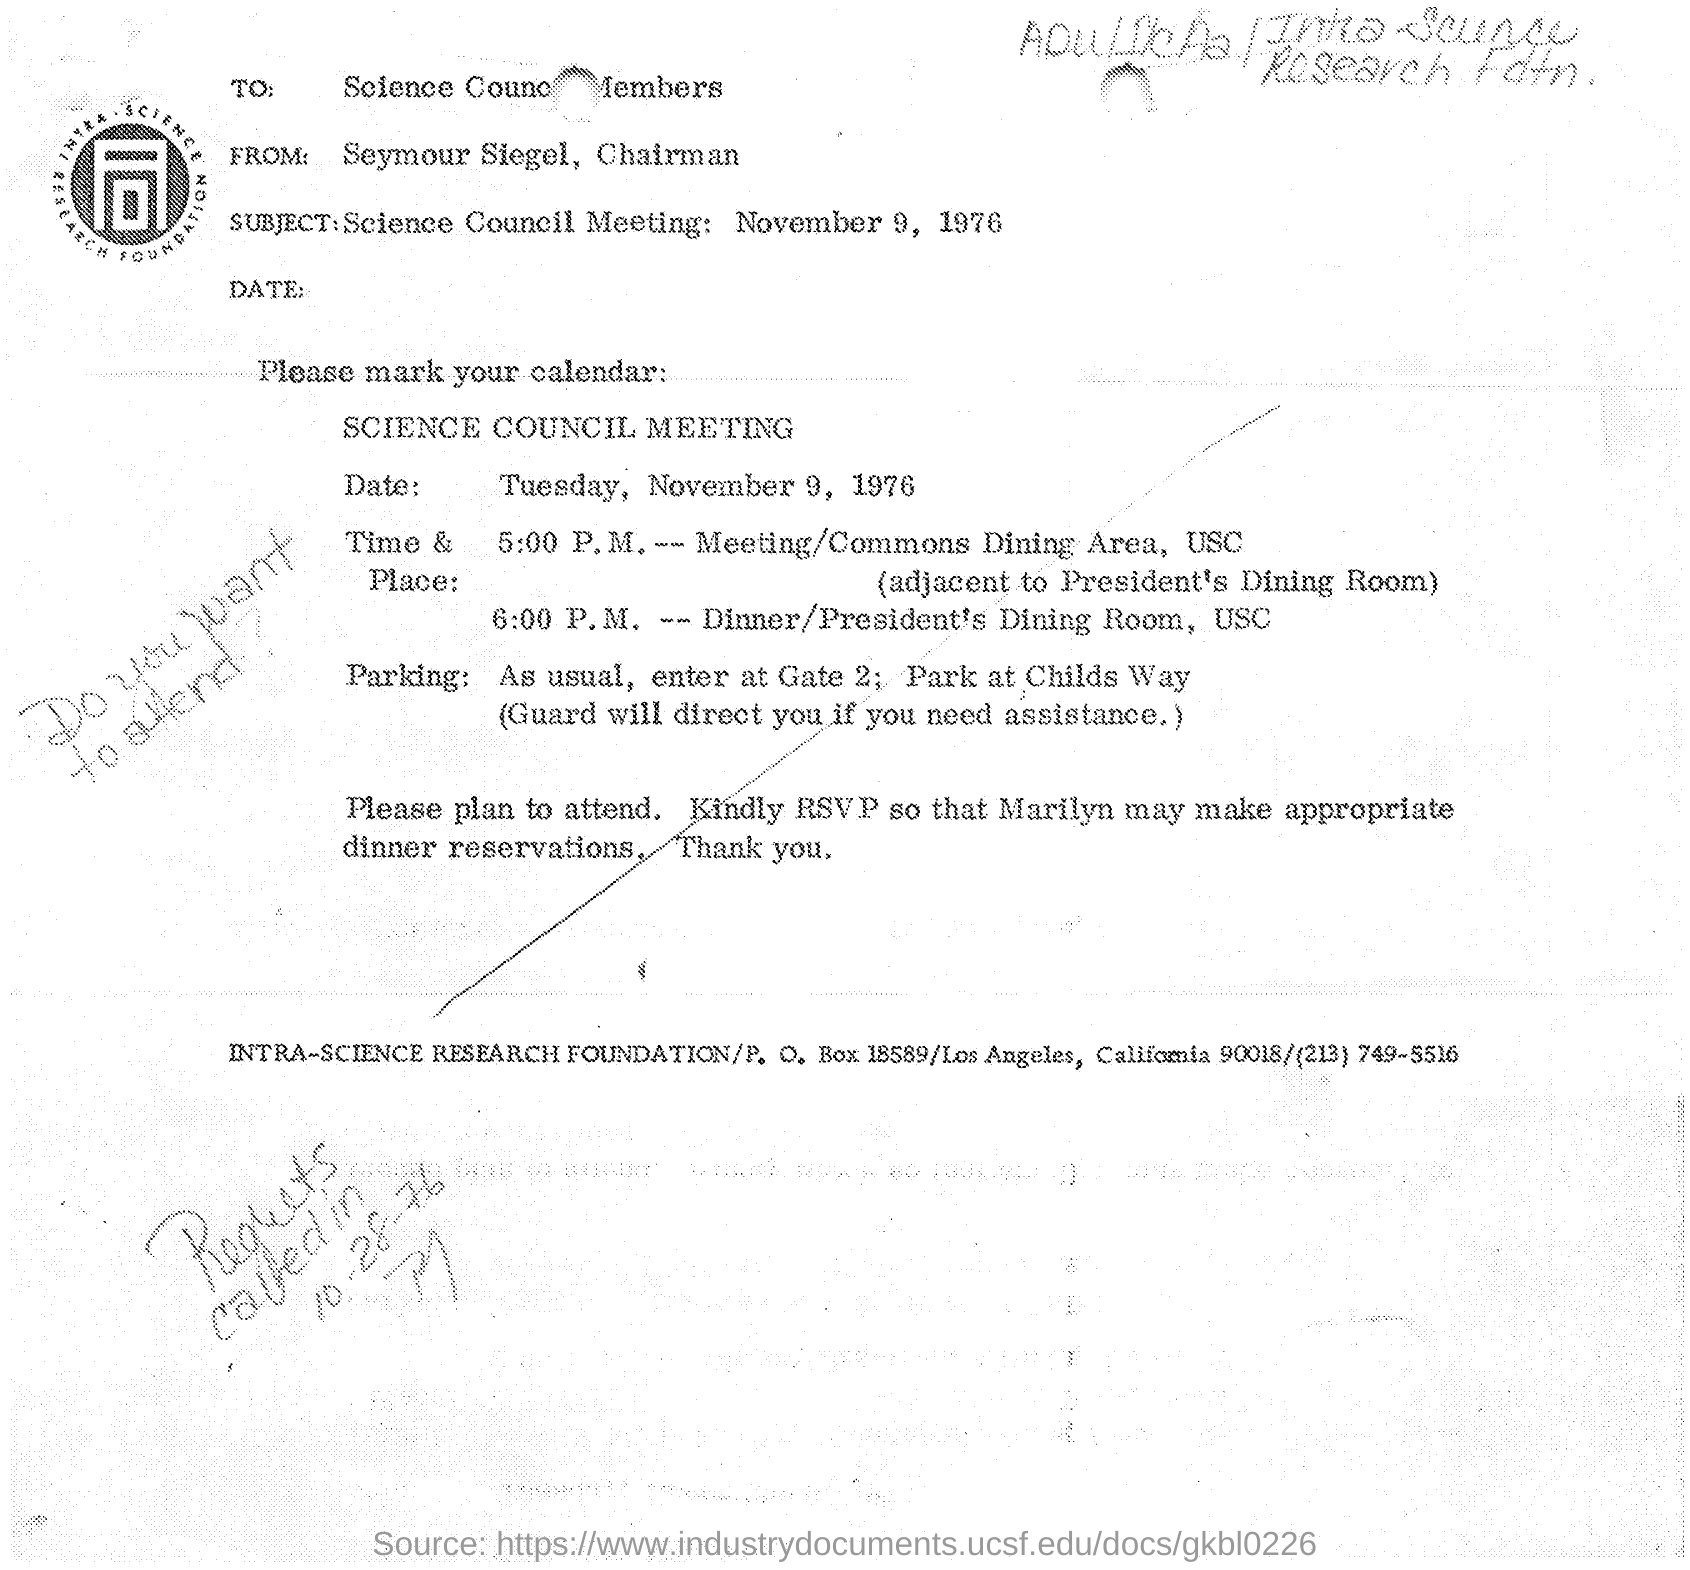Mention a couple of crucial points in this snapshot. The sender of this document is Seymour Siegel, its Chairman. This is the schedule of the meeting of INTRA-SCIENCE RESEARCH FOUNDATION. The Science Council Meeting will be held on Tuesday, November 9, 1976. The recipient of this document is the Science Council Members. The subject discussed at the Science Council Meeting held on November 9, 1976, is. 